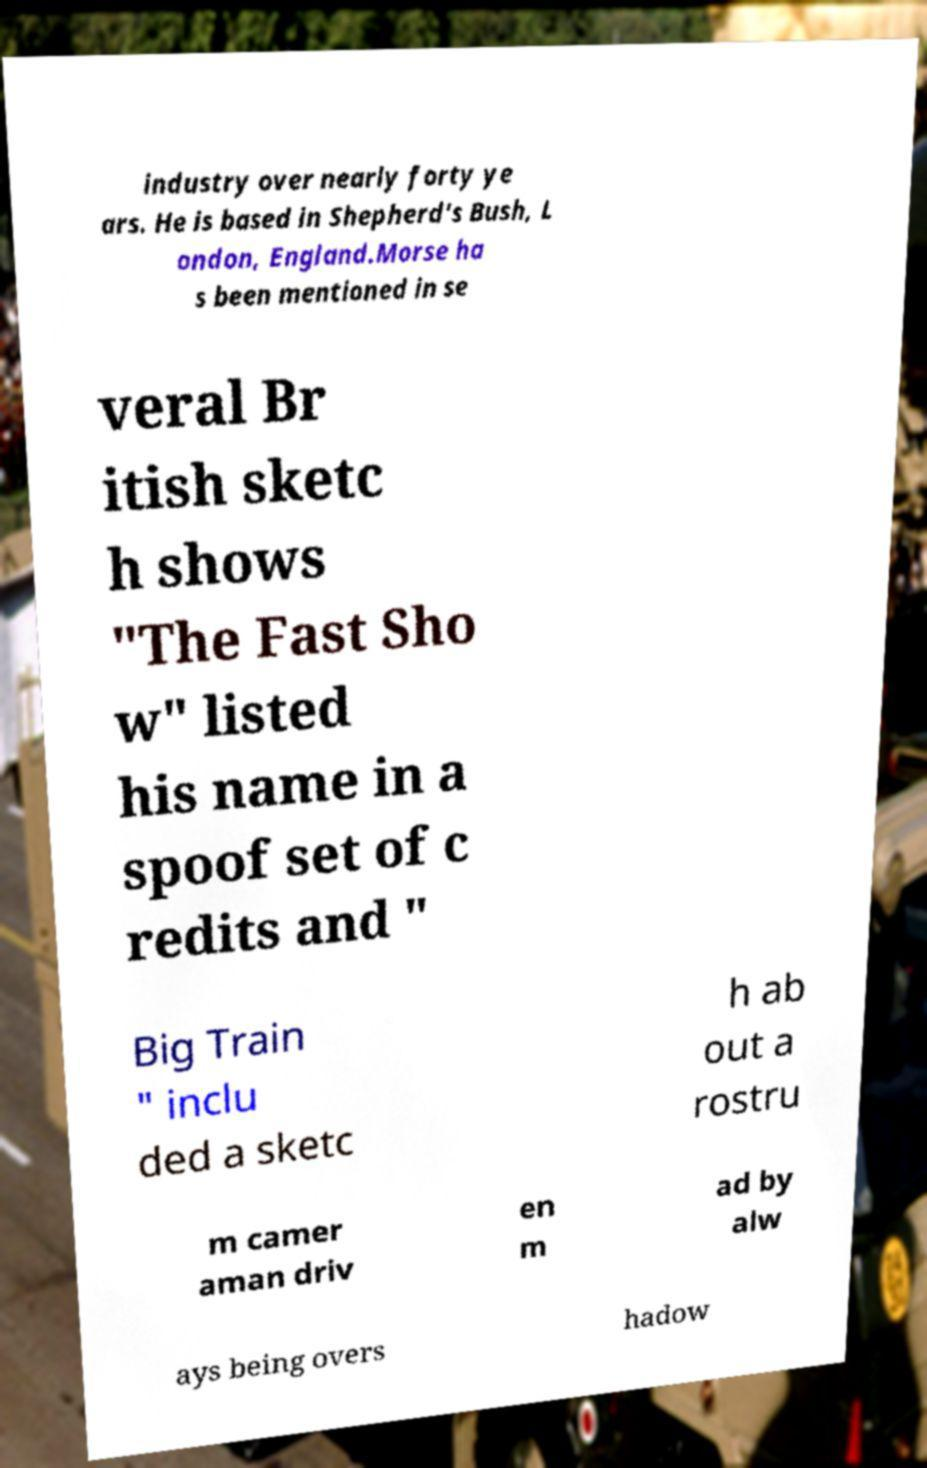Please identify and transcribe the text found in this image. industry over nearly forty ye ars. He is based in Shepherd's Bush, L ondon, England.Morse ha s been mentioned in se veral Br itish sketc h shows "The Fast Sho w" listed his name in a spoof set of c redits and " Big Train " inclu ded a sketc h ab out a rostru m camer aman driv en m ad by alw ays being overs hadow 